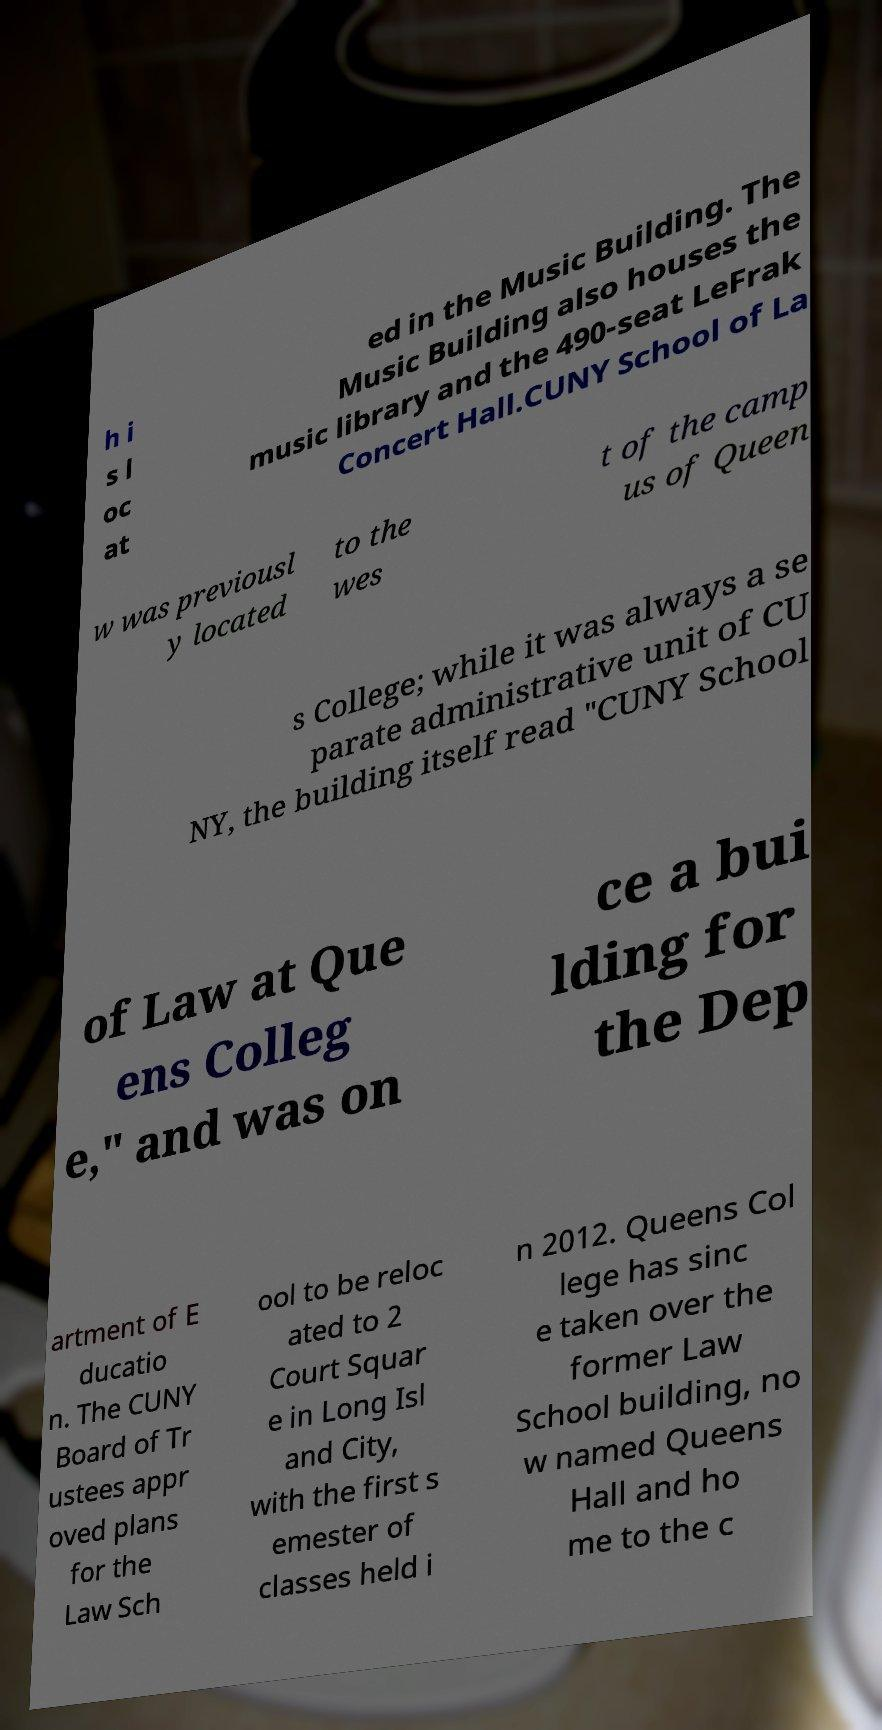Please identify and transcribe the text found in this image. h i s l oc at ed in the Music Building. The Music Building also houses the music library and the 490-seat LeFrak Concert Hall.CUNY School of La w was previousl y located to the wes t of the camp us of Queen s College; while it was always a se parate administrative unit of CU NY, the building itself read "CUNY School of Law at Que ens Colleg e," and was on ce a bui lding for the Dep artment of E ducatio n. The CUNY Board of Tr ustees appr oved plans for the Law Sch ool to be reloc ated to 2 Court Squar e in Long Isl and City, with the first s emester of classes held i n 2012. Queens Col lege has sinc e taken over the former Law School building, no w named Queens Hall and ho me to the c 